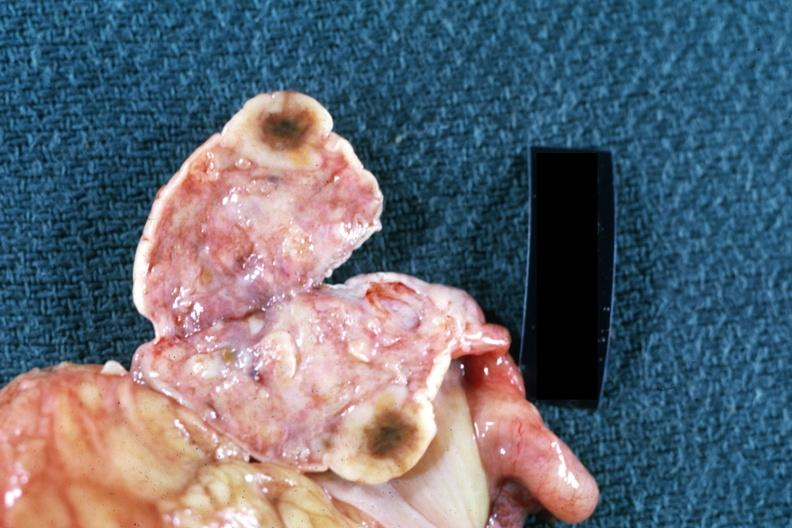s female reproductive present?
Answer the question using a single word or phrase. Yes 